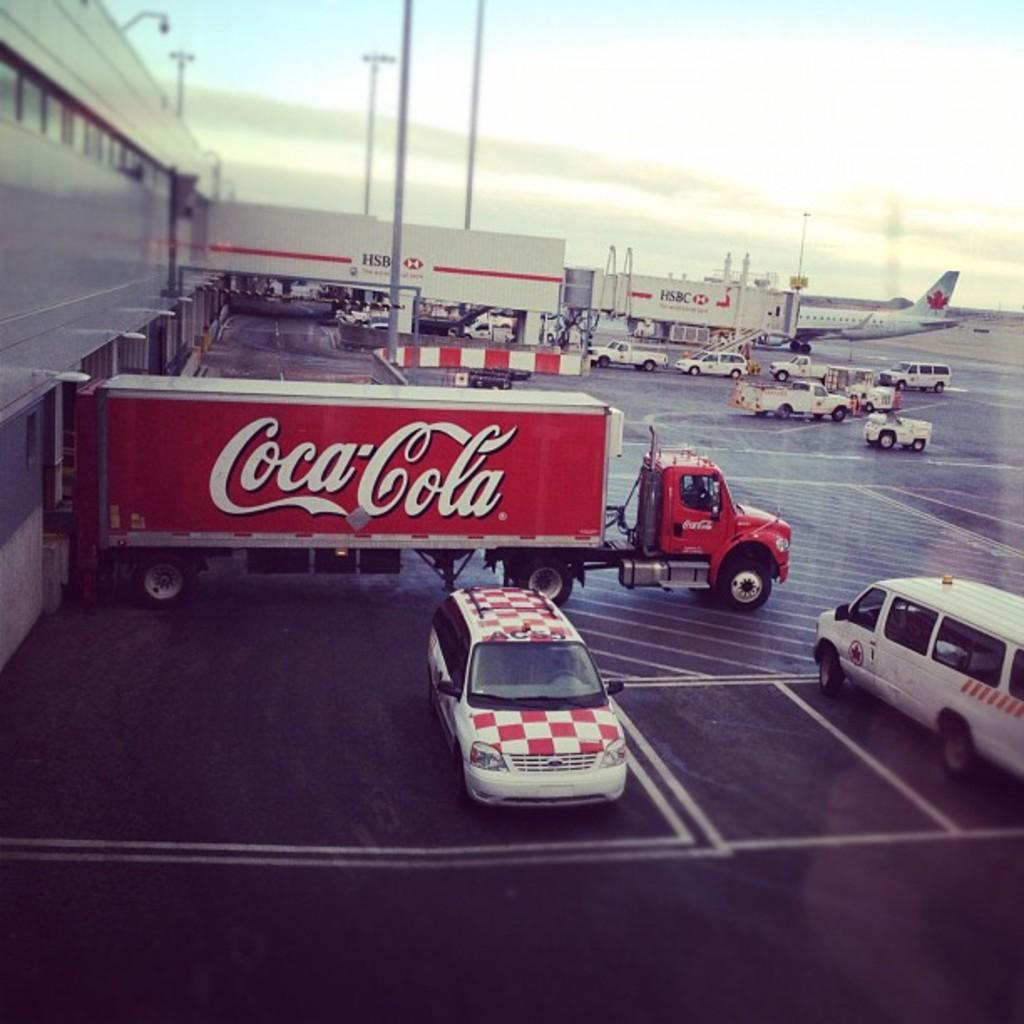What types of vehicles are in the image? There are vehicles in the image, but the specific types are not mentioned. What is the main mode of transportation in the image? The main mode of transportation in the image is an aircraft. What can be seen in the background of the image? There are poles and the sky visible in the background of the image. What committee is responsible for organizing the holiday depicted in the image? There is no holiday depicted in the image, so there is no committee responsible for organizing it. 